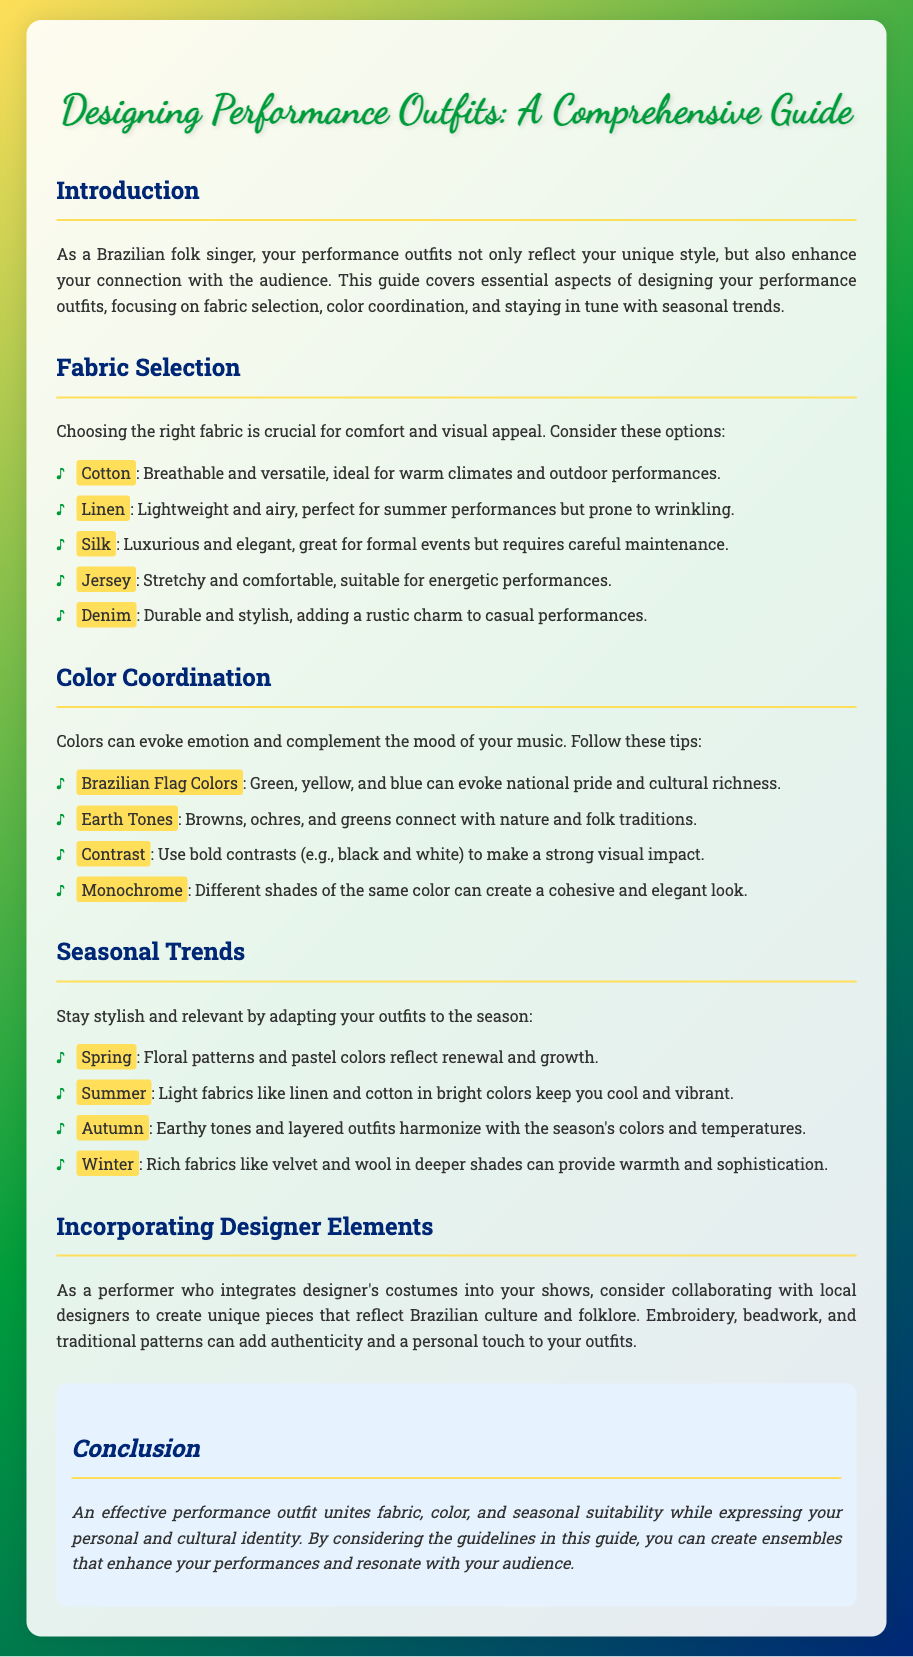What are the key aspects of designing performance outfits? The key aspects are fabric selection, color coordination, and seasonal trends.
Answer: Fabric selection, color coordination, and seasonal trends Which fabric is described as lightweight and airy? Linen is specifically mentioned as lightweight and airy, perfect for summer performances.
Answer: Linen What colors evoke national pride according to the document? The document states that Brazilian Flag Colors (green, yellow, and blue) evoke national pride.
Answer: Green, yellow, and blue What season is associated with floral patterns? The document mentions that floral patterns are reflective of Spring.
Answer: Spring What type of fabrics are suggested for Winter outfits? The guide suggests using rich fabrics like velvet and wool for Winter.
Answer: Velvet and wool What is emphasized for creating unique pieces? Collaborating with local designers is emphasized for creating unique pieces.
Answer: Collaborating with local designers What does a monochrome look consist of? A monochrome look consists of different shades of the same color.
Answer: Different shades of the same color Which season requires light fabrics to stay cool? The document indicates that Summer requires light fabrics for vibrancy and cooling.
Answer: Summer What design elements can add authenticity to outfits? Embroidery, beadwork, and traditional patterns can add authenticity.
Answer: Embroidery, beadwork, and traditional patterns 